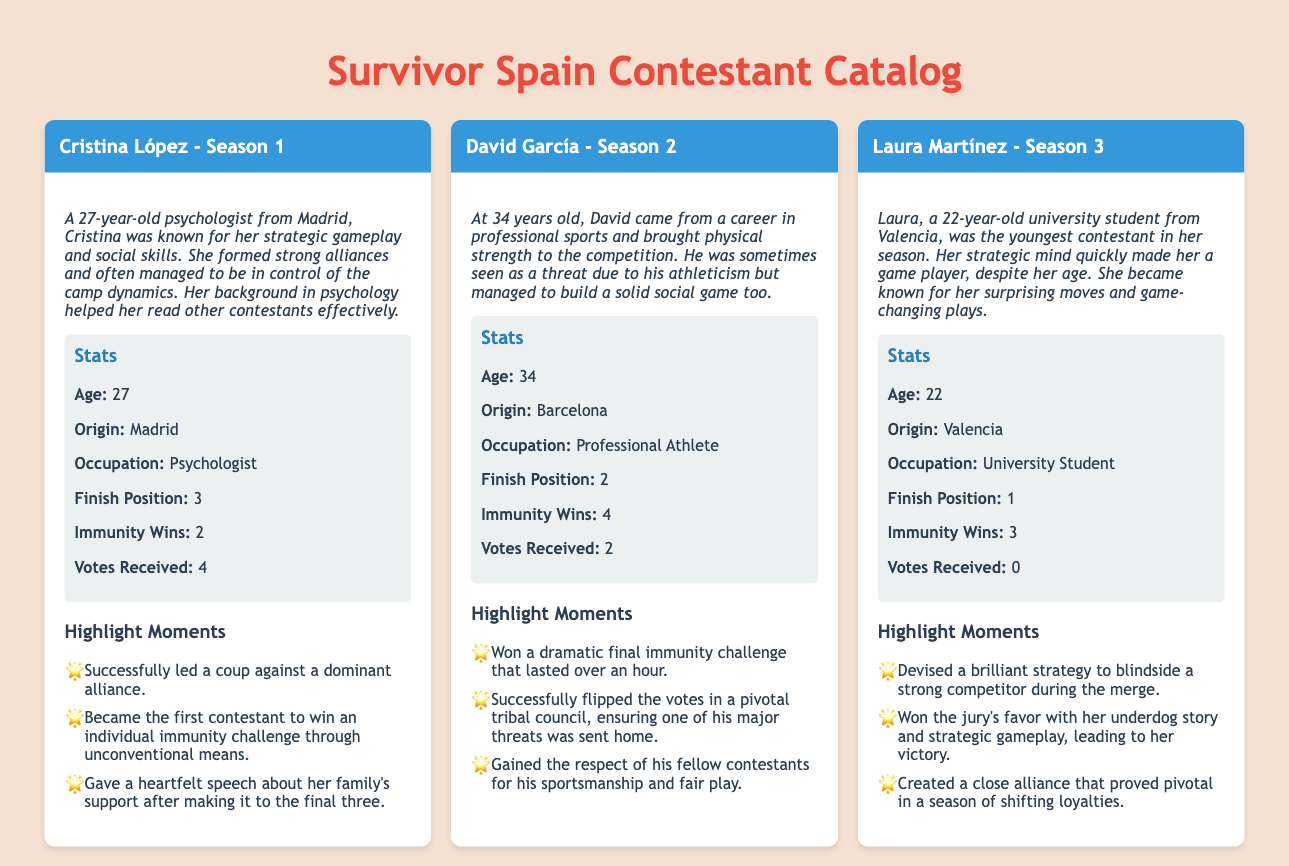What is Cristina's occupation? Cristina's profile states she is a psychologist.
Answer: Psychologist How many immunity wins did David García have? The stats section for David mentions he had 4 immunity wins.
Answer: 4 What is Laura Martínez's finish position in her season? Laura's stats indicate that she finished in the 1st position.
Answer: 1 Which contestant is from Barcelona? The document specifies that David García is from Barcelona.
Answer: David García What was a highlight moment for Cristina López? One of the highlight moments was that she successfully led a coup against a dominant alliance.
Answer: Successfully led a coup What age was Laura Martínez during her season? Laura's profile indicates she was 22 years old.
Answer: 22 How many votes did Laura receive? According to the stats, Laura received 0 votes.
Answer: 0 Which season did David García compete in? The contestant header for David indicates he participated in Season 2.
Answer: Season 2 What trait helped Cristina read other contestants effectively? The bio mentions that her background in psychology helped her read others.
Answer: Psychology 